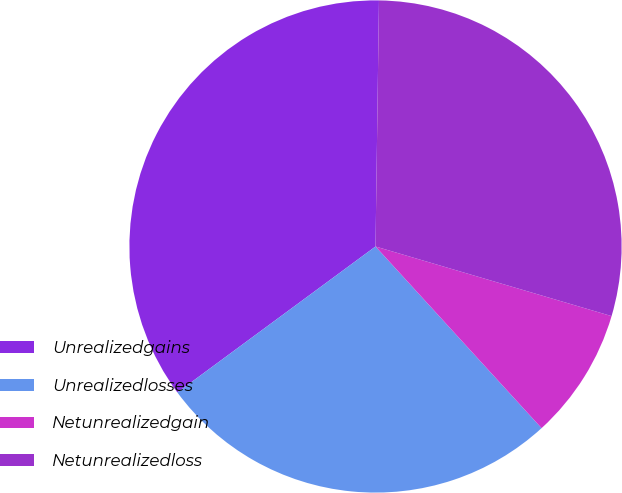Convert chart to OTSL. <chart><loc_0><loc_0><loc_500><loc_500><pie_chart><fcel>Unrealizedgains<fcel>Unrealizedlosses<fcel>Netunrealizedgain<fcel>Netunrealizedloss<nl><fcel>35.33%<fcel>26.68%<fcel>8.65%<fcel>29.34%<nl></chart> 